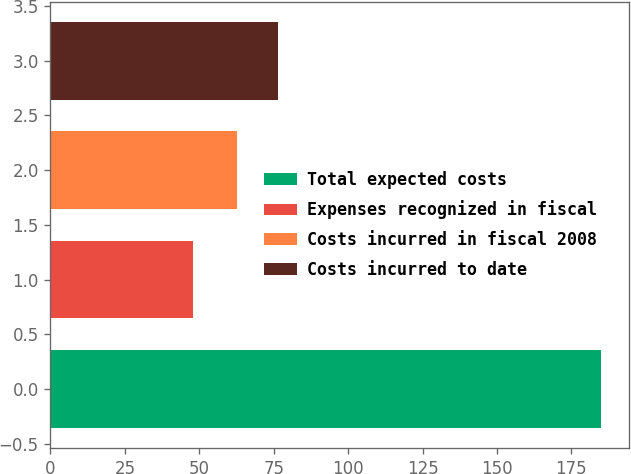<chart> <loc_0><loc_0><loc_500><loc_500><bar_chart><fcel>Total expected costs<fcel>Expenses recognized in fiscal<fcel>Costs incurred in fiscal 2008<fcel>Costs incurred to date<nl><fcel>185<fcel>47.8<fcel>62.6<fcel>76.32<nl></chart> 